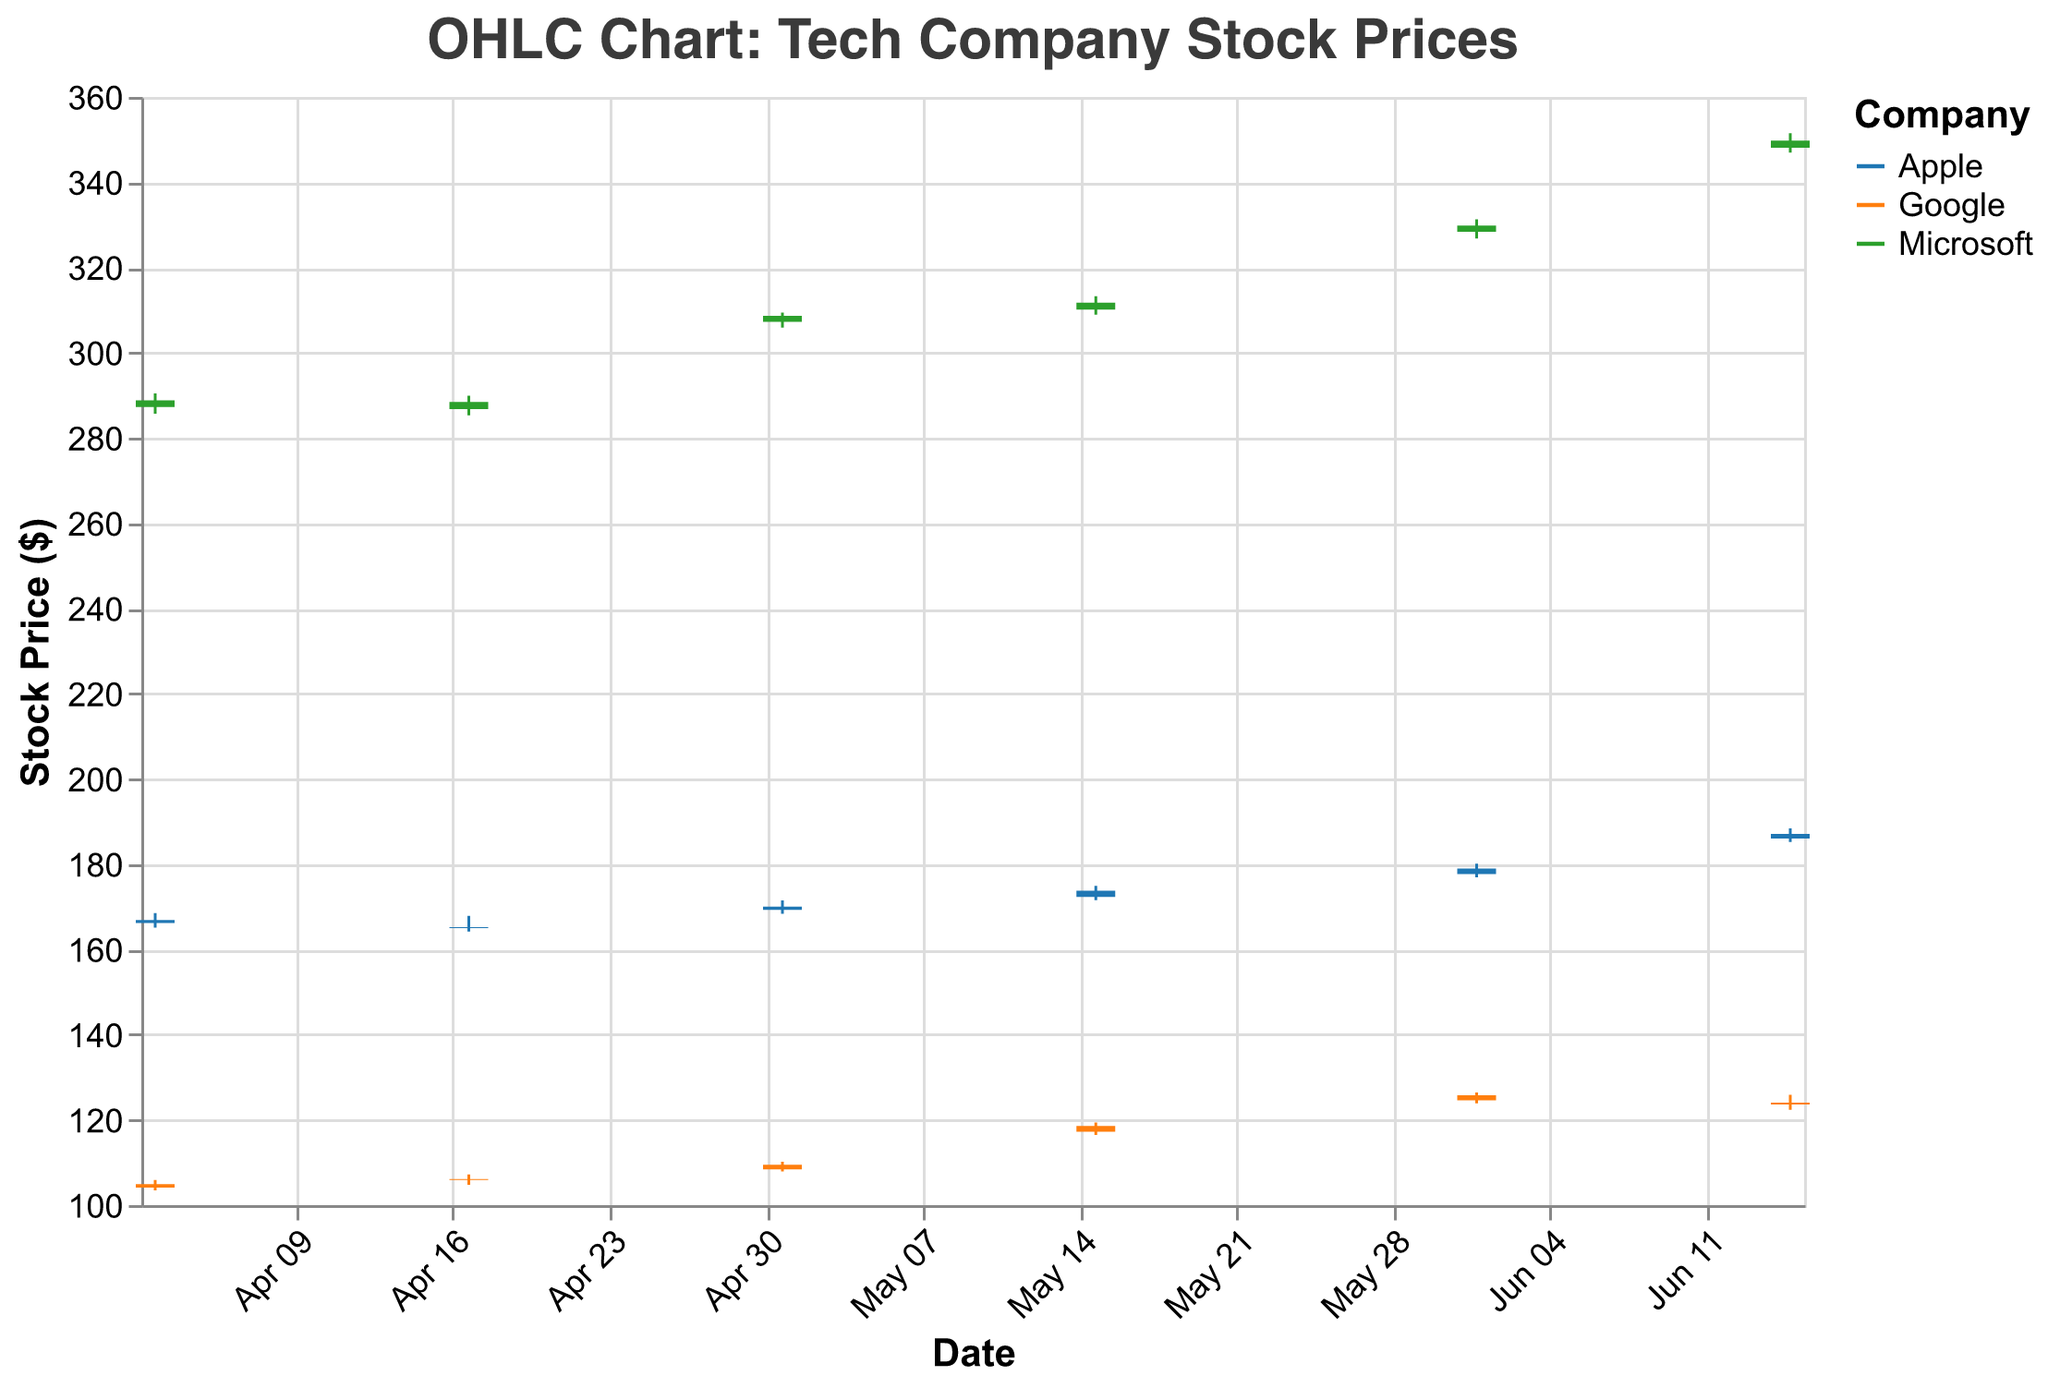What's the title of the chart? The title is usually found at the top of the chart and it summarizes what the chart is about.
Answer: OHLC Chart: Tech Company Stock Prices What are the three companies shown in the chart? The companies are distinguished by different colors in the legend, which is typically located on the right or left side of the chart.
Answer: Apple, Microsoft, Google Which company had the highest closing price on June 15, 2023? To find this, look for the date "June 15" on the x-axis and then find the closing prices for all three companies listed under that date. Microsoft has the highest closing price.
Answer: Microsoft What is the average opening price of Apple in the given data? To calculate the average opening price for Apple, sum the opening prices for all dates and divide by the number of dates. (166.89 + 165.01 + 169.28 + 172.31 + 177.70 + 186.01) / 6 = 173.20
Answer: 173.20 Which day had the largest price difference for Google, and what was the difference? Calculate the price difference (High - Low) for Google on each day and then identify the day with the largest difference. May 15 had a difference of (119.38 - 116.45) = 2.93 which is the largest.
Answer: May 15, 2.93 Compare the closing price trend of Microsoft and Apple. Which company had a higher overall increase between April 3, 2023, and June 15, 2023? Look at the closing prices for both companies on April 3 and June 15, then find the difference. Microsoft: (349.78 - 288.80) = 60.98, Apple: (187.12 - 166.17) = 20.95. Microsoft had a higher overall increase.
Answer: Microsoft Did any company have a closing price equal to its opening price on any day? Compare the opening and closing prices for all the companies on each date. No company's closing price is equal to its opening price on any day.
Answer: No On which date did Apple have the lowest closing price, and what was it? Check Apple's closing prices on all dates and find the lowest value. April 17 had the lowest closing price of 165.23.
Answer: April 17, 165.23 How many times did Google’s stock close higher than its opening price? For each date, check if Google's closing price is higher than its opening price. This occurs on April 17, May 1, and May 15 making a total of 3 times.
Answer: 3 times 